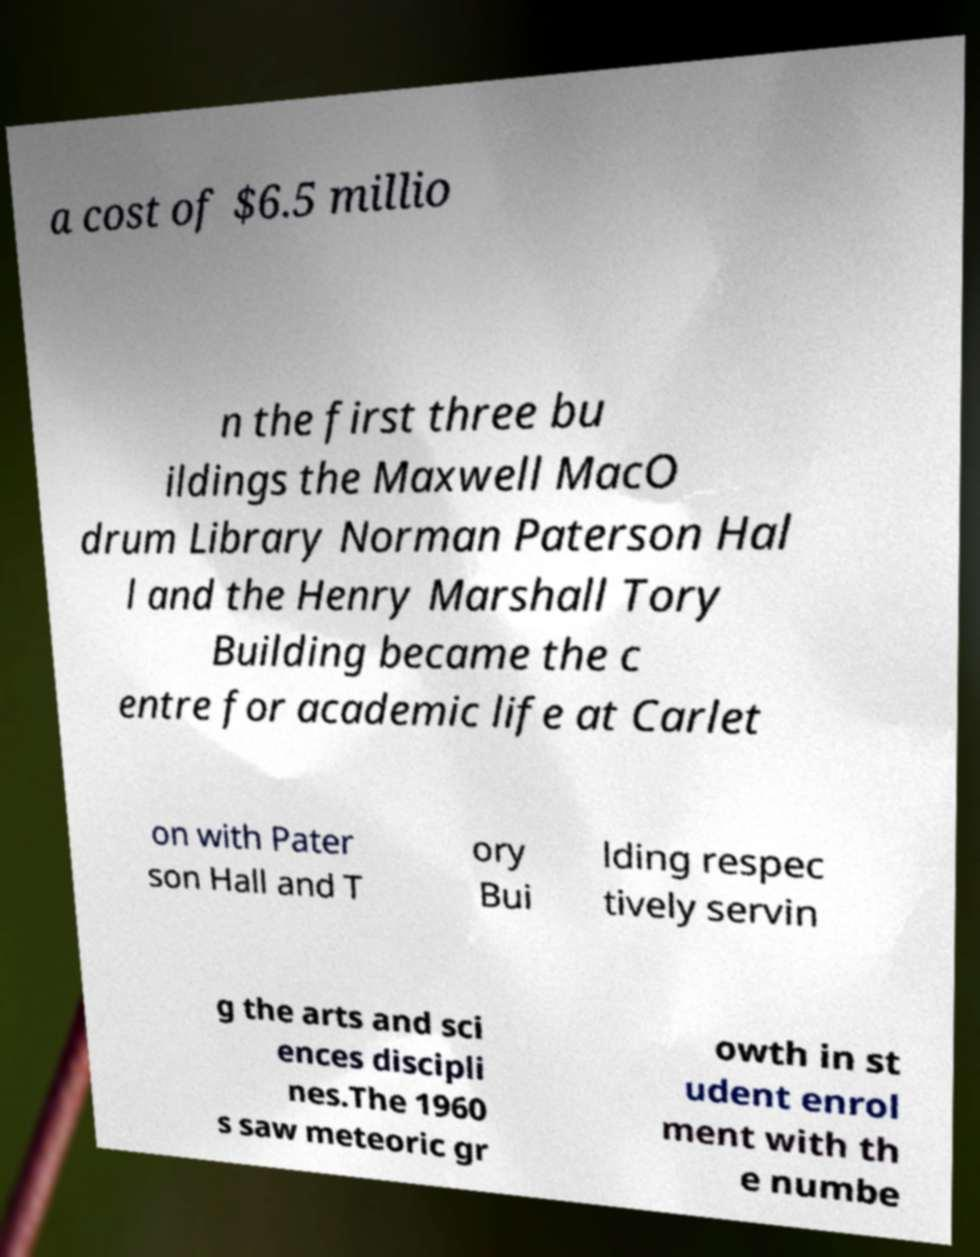Please identify and transcribe the text found in this image. a cost of $6.5 millio n the first three bu ildings the Maxwell MacO drum Library Norman Paterson Hal l and the Henry Marshall Tory Building became the c entre for academic life at Carlet on with Pater son Hall and T ory Bui lding respec tively servin g the arts and sci ences discipli nes.The 1960 s saw meteoric gr owth in st udent enrol ment with th e numbe 